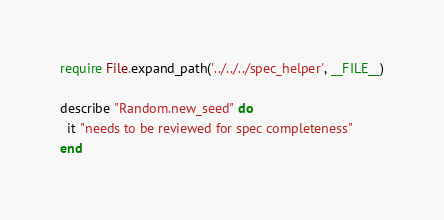<code> <loc_0><loc_0><loc_500><loc_500><_Ruby_>require File.expand_path('../../../spec_helper', __FILE__)

describe "Random.new_seed" do
  it "needs to be reviewed for spec completeness"
end
</code> 